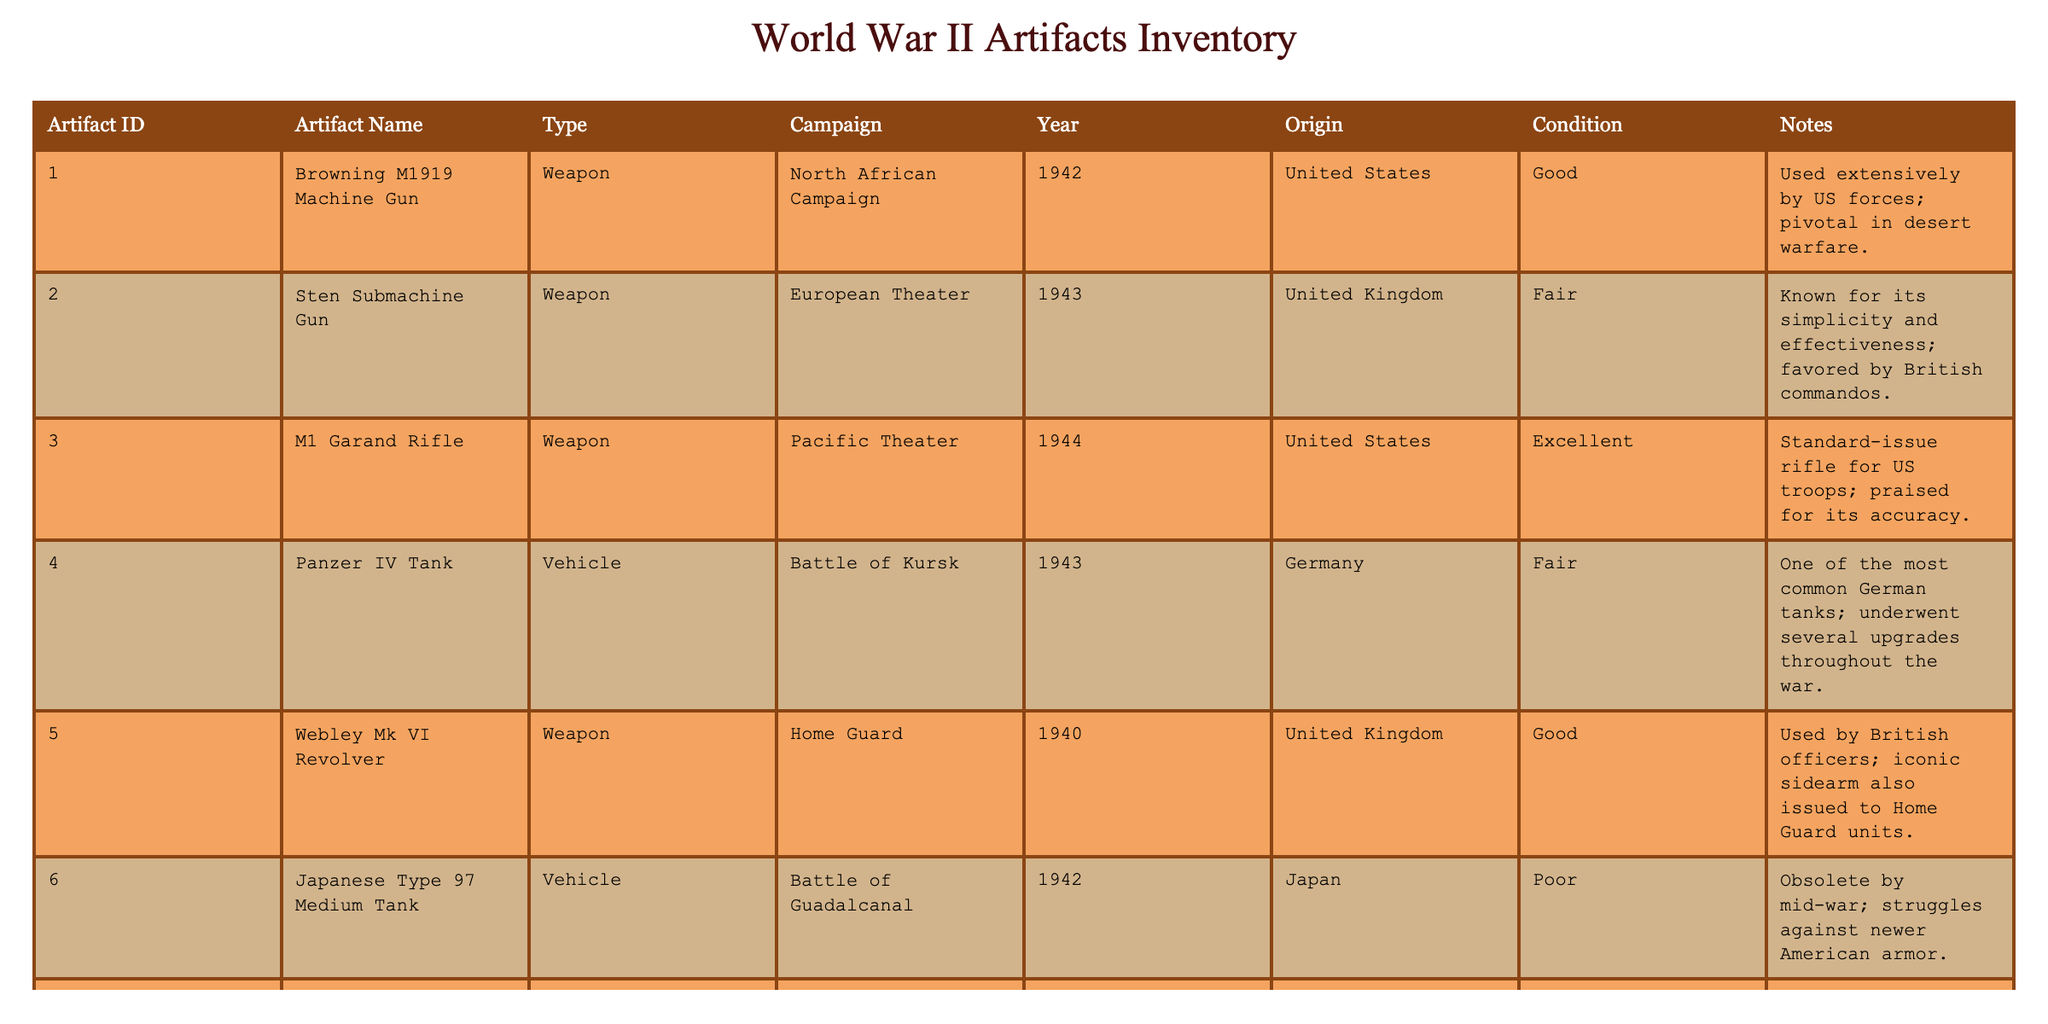What is the artifact name associated with the ID 003? The table lists the artifact ID in one column and corresponding names in another. By locating ID 003, we see that it corresponds to the name "M1 Garand Rifle".
Answer: M1 Garand Rifle Which campaign does the Panzer IV Tank belong to? To find out the campaign associated with the Panzer IV Tank, look for its entry in the table. The campaign listed alongside it is "Battle of Kursk".
Answer: Battle of Kursk How many different types of artifacts are listed in the table? The types of artifacts can be counted by reviewing the "Type" column. There are three distinct types: Weapon, Vehicle, and Personal Item. Therefore, the total is 3.
Answer: 3 What is the average year of the artifacts in the table? To calculate the average year, we sum up the years of all artifacts: (1942 + 1943 + 1944 + 1943 + 1940 + 1942 + 1939 + 1944 + 1944 + 1940) = 1943. The total number of artifacts is 10, so the average year is 1943/10 = 1943.
Answer: 1943 Is the Japanese Type 97 Medium Tank in good condition? Checking the "Condition" column for the Japanese Type 97 Medium Tank, we see it is listed as "Poor". Thus, the answer to whether it is in good condition is no.
Answer: No Which country produced the M1943 Field Jacket? The country of origin for the M1943 Field Jacket can be found in the "Origin" column. It shows the United States as the producer of this artifact.
Answer: United States How many artifacts are in "Good" condition? To find the number of artifacts in "Good" condition, we can count the entries in the "Condition" column that are labeled as "Good". The count is 5 artifacts that fit this description.
Answer: 5 Did any of the artifacts originate from multiple countries? Evaluating the "Origin" column shows that all artifacts list either a single country or "Various". However, there are no entries that specify multiple distinct countries for their origin. Hence, the answer is no.
Answer: No Which weapon has the highest condition rating in the table? Looking at the condition ratings in the "Condition" column for the Weapons, we have: Browning M1919 (Good), Sten Submachine Gun (Fair), M1 Garand Rifle (Excellent), and Webley Mk VI (Good). The highest condition rating among these weapons is "Excellent" for the M1 Garand Rifle.
Answer: M1 Garand Rifle 